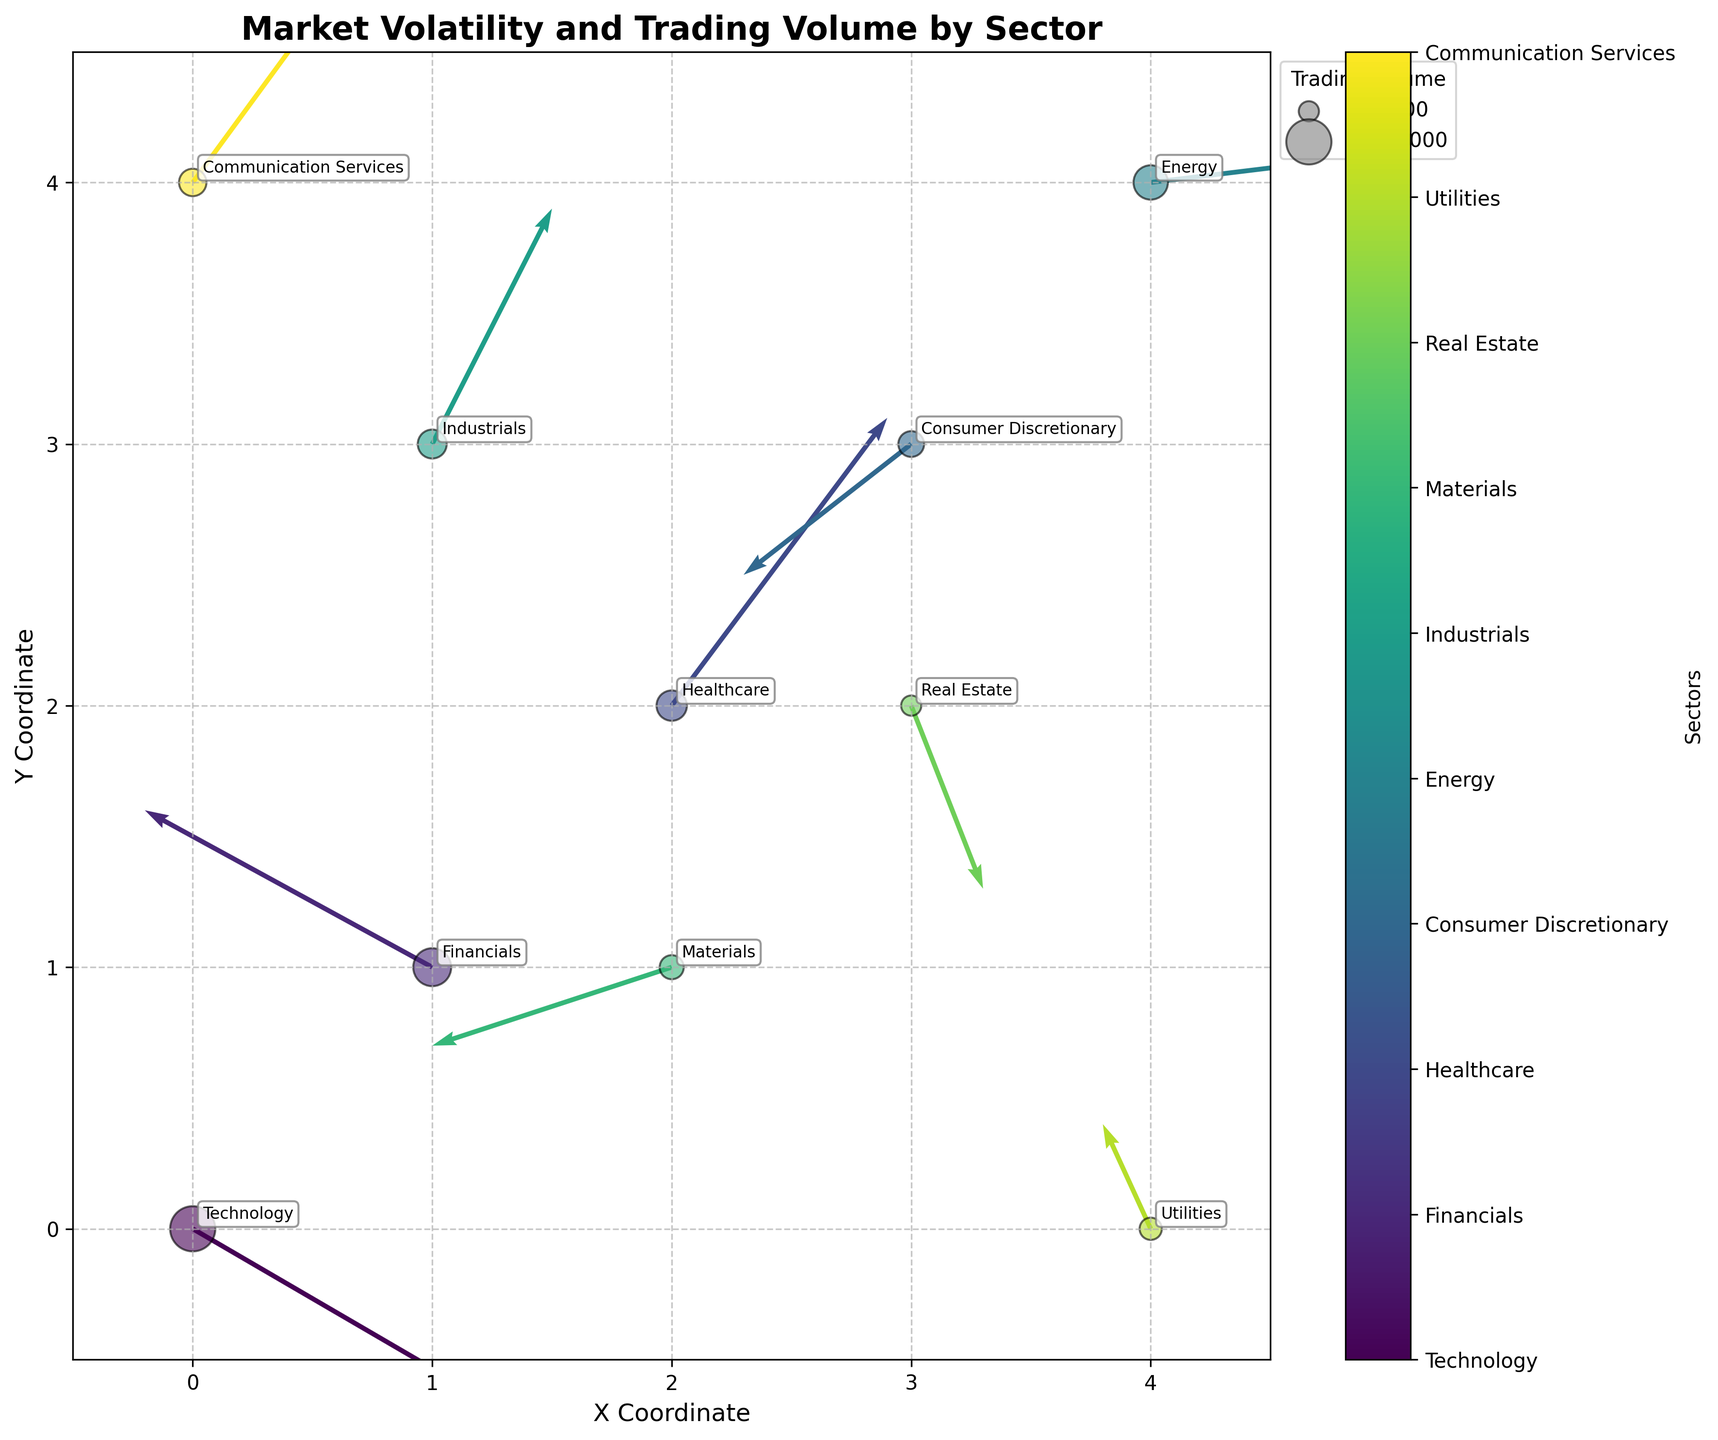What is the title of the figure? The title of the figure is shown at the top, and it summarizes what the plot is about. The title reads "Market Volatility and Trading Volume by Sector."
Answer: Market Volatility and Trading Volume by Sector What is represented by the size of the scatter points? Each scatter point represents the trading volume of a sector. This is indicated by the plot's legend, where marker size corresponds to volume, increasing as trading volume increases.
Answer: Trading volume Which sector has the largest trading volume? The scatter point with the largest marker size indicates the sector with the largest trading volume. From the plot, we see that "Technology" has the largest marker size.
Answer: Technology Which sectors exhibit a positive U and V component? We need to identify sectors whose arrows point in both positive x (U) and y (V) directions. From the plot, "Healthcare" (0.09, 0.11) and "Communication Services" (0.08, 0.10) exhibit positive U and V components.
Answer: Healthcare and Communication Services Which sector has the smallest trading volume and where is it located on the plot? The scatter point with the smallest marker size represents the sector with the smallest trading volume. From the plot, "Real Estate" has the smallest marker size. It is located at (3, 2).
Answer: Real Estate, (3, 2) What is the direction and magnitude of the vector for the "Financials" sector? The vector direction for "Financials" can be found by its components, U and V, and its magnitude can be calculated. The components are (-0.12, 0.06). The magnitude can be calculated using the Pythagorean theorem: sqrt((-0.12)^2 + (0.06)^2) ≈ 0.134
Answer: Direction: (-0.12, 0.06), Magnitude: 0.134 Compare the vectors of "Energy" and "Healthcare". Which sector's vector points more to the right? We compare the U components of both sectors' vectors. "Energy" has U = 0.18, and "Healthcare" has U = 0.09. Since 0.18 > 0.09, "Energy" points more to the right.
Answer: Energy Identify the sector with a negative U and positive V component located closest to the origin. We need to find a sector with a U < 0 and V > 0 and compare their distances to the origin using their coordinates. "Financials" (1, 1) with (-0.12, 0.06) and "Utilities" (4, 0) with (-0.02, 0.04). "Financials" is closer to the origin (sqrt(1^2 + 1^2) = sqrt2 ≈ 1.41 vs. sqrt16 = 4).
Answer: Financials What is the average trading volume of the top three sectors with the highest volumes? Identify the top three sectors with the largest marker sizes: Technology (2,500,000), Financials (1,800,000), and Energy (1,500,000). Calculate the average: (2,500,000 + 1,800,000 + 1,500,000) / 3 ≈ 1,933,333.33
Answer: 1,933,333.33 Which sector has the steepest downward trend in market volatility and in which directions do its components point? The steepest downward trend is represented by the vector with the most negative V component. "Technology" has U = 0.15 and V = -0.08, which is the most negative V component. The components point right (positive) and downward (negative).
Answer: Technology, right and downward 